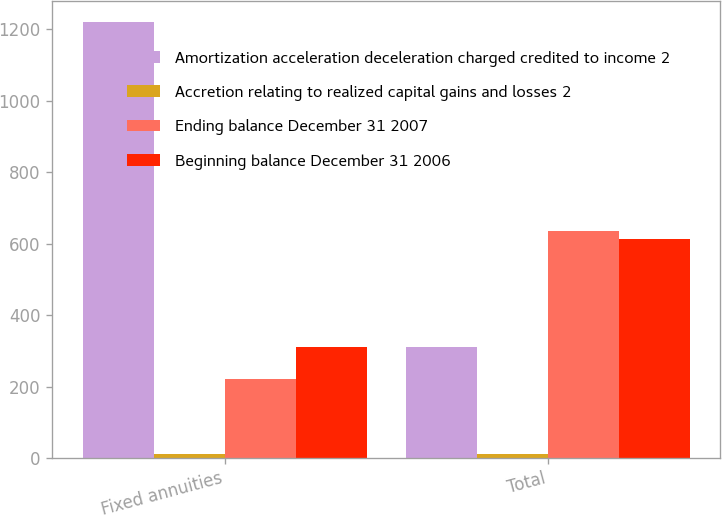Convert chart. <chart><loc_0><loc_0><loc_500><loc_500><stacked_bar_chart><ecel><fcel>Fixed annuities<fcel>Total<nl><fcel>Amortization acceleration deceleration charged credited to income 2<fcel>1219<fcel>312<nl><fcel>Accretion relating to realized capital gains and losses 2<fcel>11<fcel>11<nl><fcel>Ending balance December 31 2007<fcel>220<fcel>635<nl><fcel>Beginning balance December 31 2006<fcel>312<fcel>614<nl></chart> 